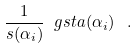<formula> <loc_0><loc_0><loc_500><loc_500>\frac { 1 } { s ( \alpha _ { i } ) } \ g s t a ( \alpha _ { i } ) \ \, .</formula> 